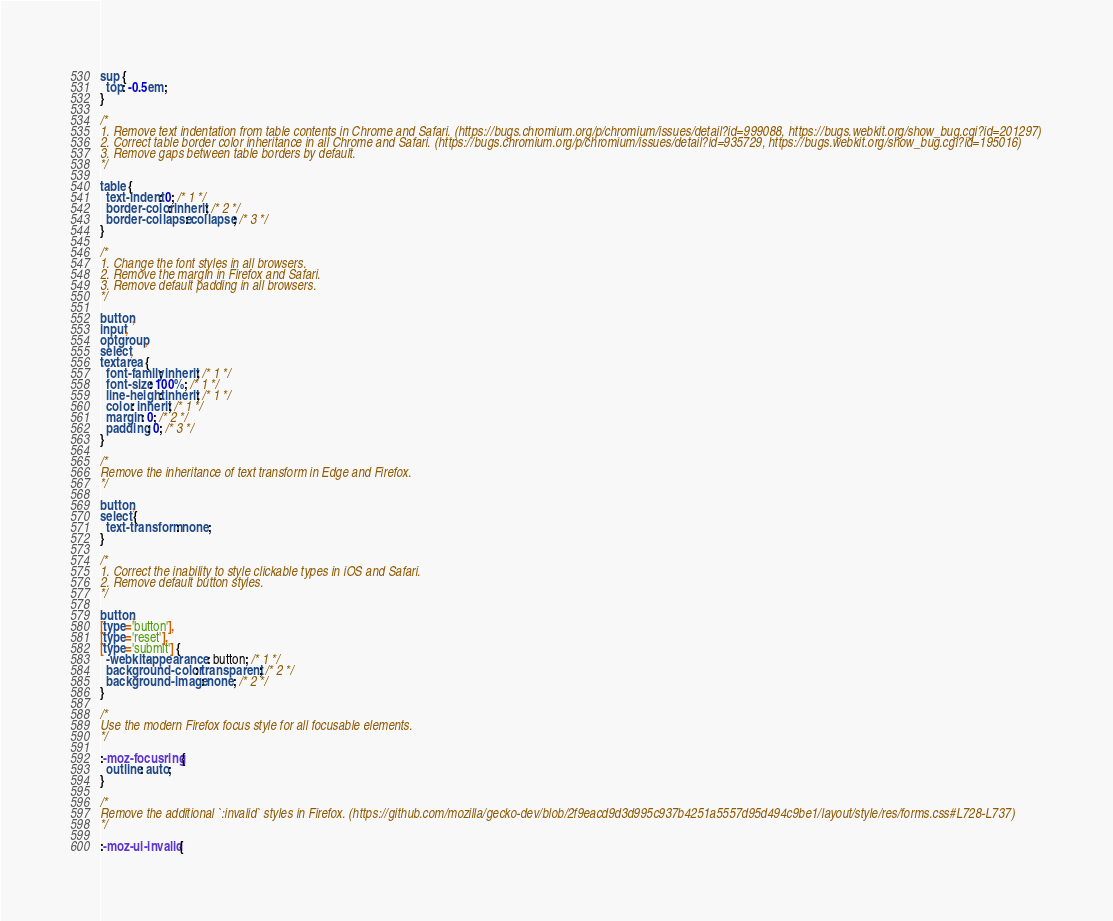<code> <loc_0><loc_0><loc_500><loc_500><_CSS_>sup {
  top: -0.5em;
}

/*
1. Remove text indentation from table contents in Chrome and Safari. (https://bugs.chromium.org/p/chromium/issues/detail?id=999088, https://bugs.webkit.org/show_bug.cgi?id=201297)
2. Correct table border color inheritance in all Chrome and Safari. (https://bugs.chromium.org/p/chromium/issues/detail?id=935729, https://bugs.webkit.org/show_bug.cgi?id=195016)
3. Remove gaps between table borders by default.
*/

table {
  text-indent: 0; /* 1 */
  border-color: inherit; /* 2 */
  border-collapse: collapse; /* 3 */
}

/*
1. Change the font styles in all browsers.
2. Remove the margin in Firefox and Safari.
3. Remove default padding in all browsers.
*/

button,
input,
optgroup,
select,
textarea {
  font-family: inherit; /* 1 */
  font-size: 100%; /* 1 */
  line-height: inherit; /* 1 */
  color: inherit; /* 1 */
  margin: 0; /* 2 */
  padding: 0; /* 3 */
}

/*
Remove the inheritance of text transform in Edge and Firefox.
*/

button,
select {
  text-transform: none;
}

/*
1. Correct the inability to style clickable types in iOS and Safari.
2. Remove default button styles.
*/

button,
[type='button'],
[type='reset'],
[type='submit'] {
  -webkit-appearance: button; /* 1 */
  background-color: transparent; /* 2 */
  background-image: none; /* 2 */
}

/*
Use the modern Firefox focus style for all focusable elements.
*/

:-moz-focusring {
  outline: auto;
}

/*
Remove the additional `:invalid` styles in Firefox. (https://github.com/mozilla/gecko-dev/blob/2f9eacd9d3d995c937b4251a5557d95d494c9be1/layout/style/res/forms.css#L728-L737)
*/

:-moz-ui-invalid {</code> 